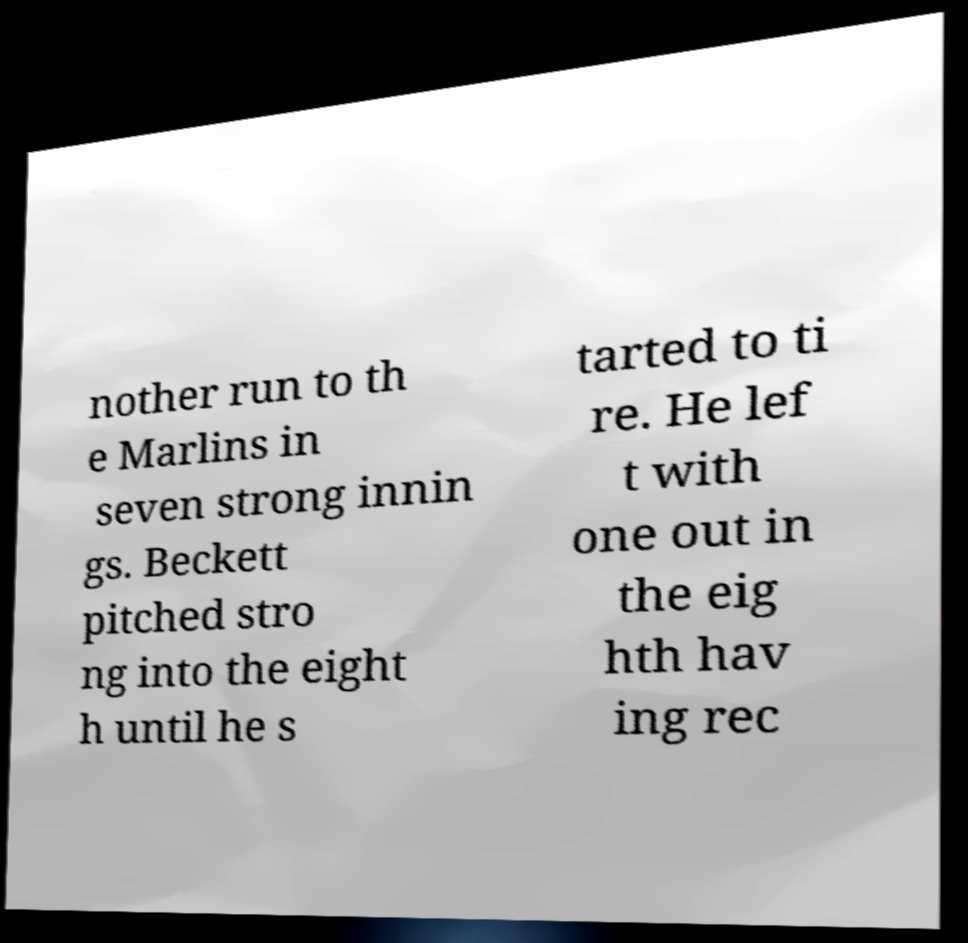Can you read and provide the text displayed in the image?This photo seems to have some interesting text. Can you extract and type it out for me? nother run to th e Marlins in seven strong innin gs. Beckett pitched stro ng into the eight h until he s tarted to ti re. He lef t with one out in the eig hth hav ing rec 